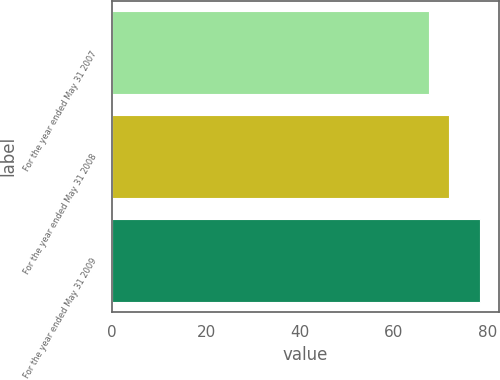Convert chart to OTSL. <chart><loc_0><loc_0><loc_500><loc_500><bar_chart><fcel>For the year ended May 31 2007<fcel>For the year ended May 31 2008<fcel>For the year ended May 31 2009<nl><fcel>67.6<fcel>71.7<fcel>78.4<nl></chart> 